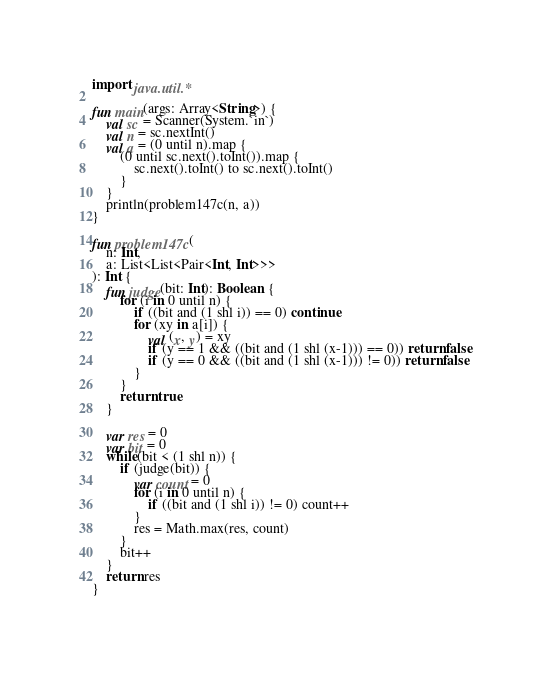<code> <loc_0><loc_0><loc_500><loc_500><_Kotlin_>import java.util.*

fun main(args: Array<String>) {
    val sc = Scanner(System.`in`)
    val n = sc.nextInt()
    val a = (0 until n).map {
        (0 until sc.next().toInt()).map {
            sc.next().toInt() to sc.next().toInt()
        }
    }
    println(problem147c(n, a))
}

fun problem147c(
    n: Int,
    a: List<List<Pair<Int, Int>>>
): Int {
    fun judge(bit: Int): Boolean {
        for (i in 0 until n) {
            if ((bit and (1 shl i)) == 0) continue
            for (xy in a[i]) {
                val (x, y) = xy
                if (y == 1 && ((bit and (1 shl (x-1))) == 0)) return false
                if (y == 0 && ((bit and (1 shl (x-1))) != 0)) return false
            }
        }
        return true
    }

    var res = 0
    var bit = 0
    while(bit < (1 shl n)) {
        if (judge(bit)) {
            var count = 0
            for (i in 0 until n) {
                if ((bit and (1 shl i)) != 0) count++
            }
            res = Math.max(res, count)
        }
        bit++
    }
    return res
}
</code> 